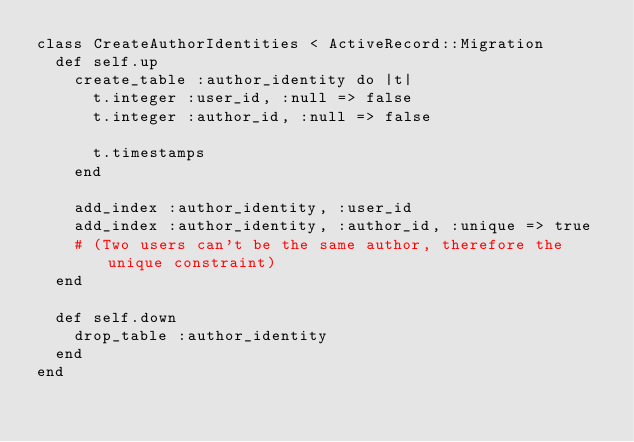Convert code to text. <code><loc_0><loc_0><loc_500><loc_500><_Ruby_>class CreateAuthorIdentities < ActiveRecord::Migration
  def self.up
    create_table :author_identity do |t|
      t.integer :user_id, :null => false
      t.integer :author_id, :null => false

      t.timestamps
    end

    add_index :author_identity, :user_id
    add_index :author_identity, :author_id, :unique => true
    # (Two users can't be the same author, therefore the unique constraint)
  end

  def self.down
    drop_table :author_identity
  end
end
</code> 